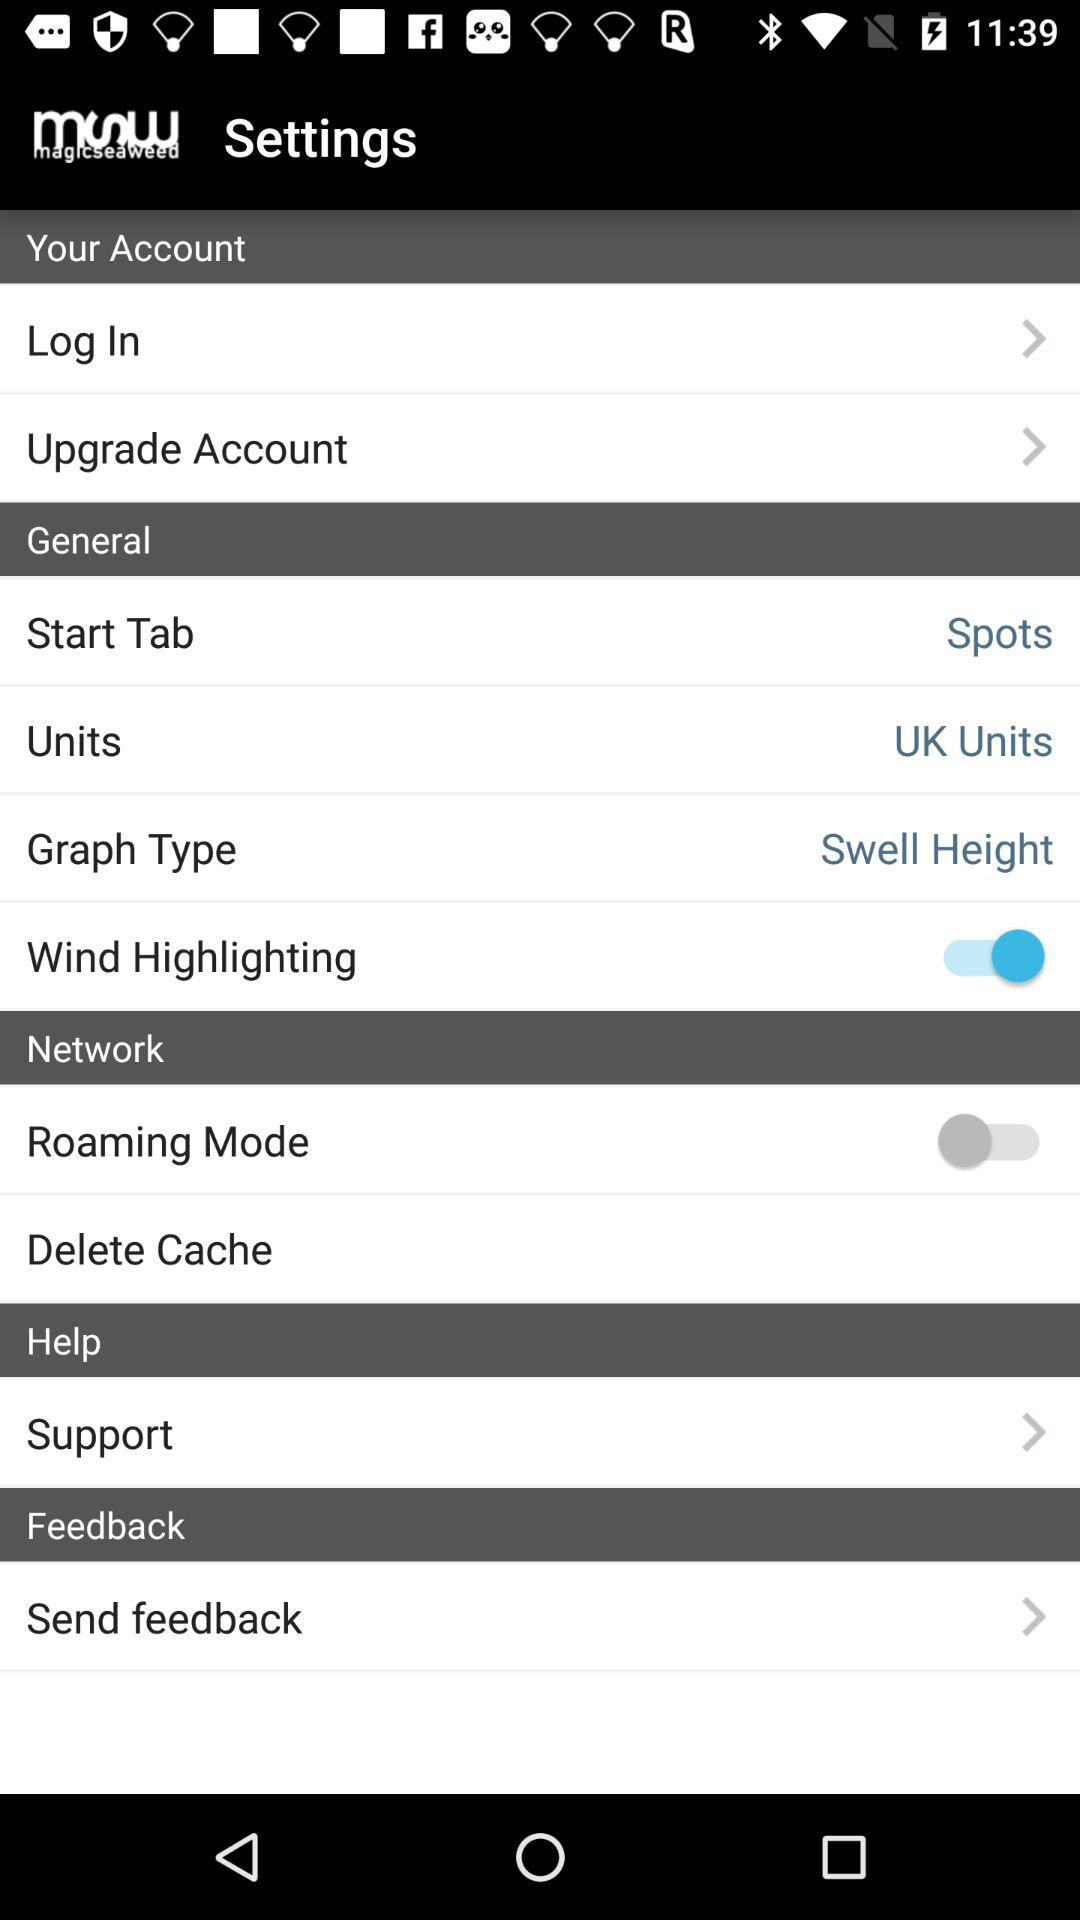What is the status of the "Units"? The status is "UK Units". 